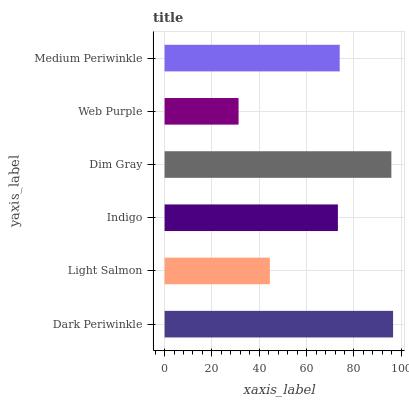Is Web Purple the minimum?
Answer yes or no. Yes. Is Dark Periwinkle the maximum?
Answer yes or no. Yes. Is Light Salmon the minimum?
Answer yes or no. No. Is Light Salmon the maximum?
Answer yes or no. No. Is Dark Periwinkle greater than Light Salmon?
Answer yes or no. Yes. Is Light Salmon less than Dark Periwinkle?
Answer yes or no. Yes. Is Light Salmon greater than Dark Periwinkle?
Answer yes or no. No. Is Dark Periwinkle less than Light Salmon?
Answer yes or no. No. Is Medium Periwinkle the high median?
Answer yes or no. Yes. Is Indigo the low median?
Answer yes or no. Yes. Is Dim Gray the high median?
Answer yes or no. No. Is Medium Periwinkle the low median?
Answer yes or no. No. 